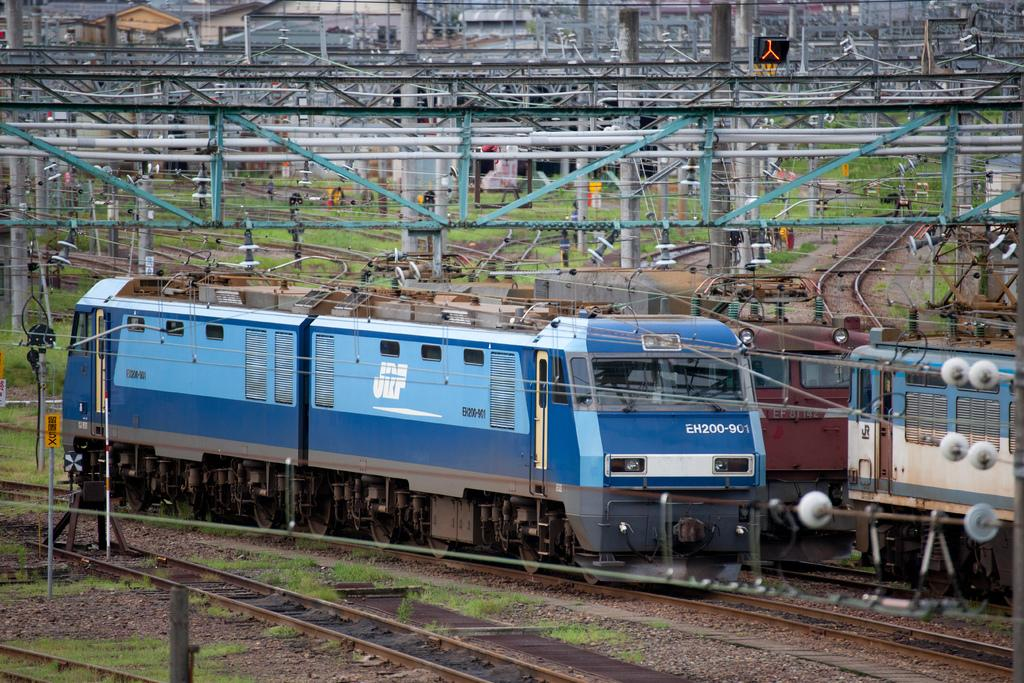<image>
Provide a brief description of the given image. A blue and white train on the rail with EH200-9 on front. 